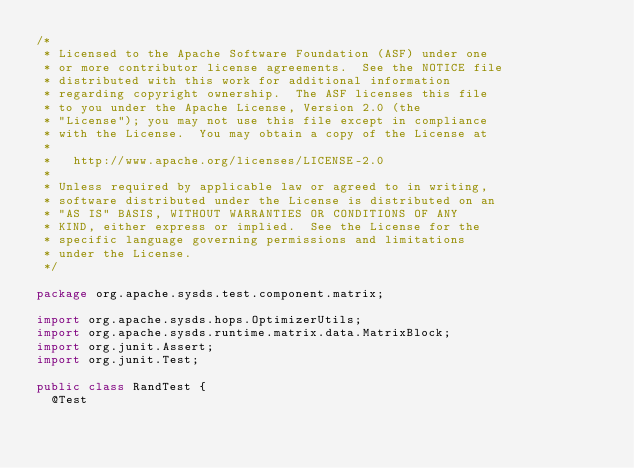<code> <loc_0><loc_0><loc_500><loc_500><_Java_>/*
 * Licensed to the Apache Software Foundation (ASF) under one
 * or more contributor license agreements.  See the NOTICE file
 * distributed with this work for additional information
 * regarding copyright ownership.  The ASF licenses this file
 * to you under the Apache License, Version 2.0 (the
 * "License"); you may not use this file except in compliance
 * with the License.  You may obtain a copy of the License at
 * 
 *   http://www.apache.org/licenses/LICENSE-2.0
 * 
 * Unless required by applicable law or agreed to in writing,
 * software distributed under the License is distributed on an
 * "AS IS" BASIS, WITHOUT WARRANTIES OR CONDITIONS OF ANY
 * KIND, either express or implied.  See the License for the
 * specific language governing permissions and limitations
 * under the License.
 */

package org.apache.sysds.test.component.matrix;

import org.apache.sysds.hops.OptimizerUtils;
import org.apache.sysds.runtime.matrix.data.MatrixBlock;
import org.junit.Assert;
import org.junit.Test;

public class RandTest {
	@Test</code> 